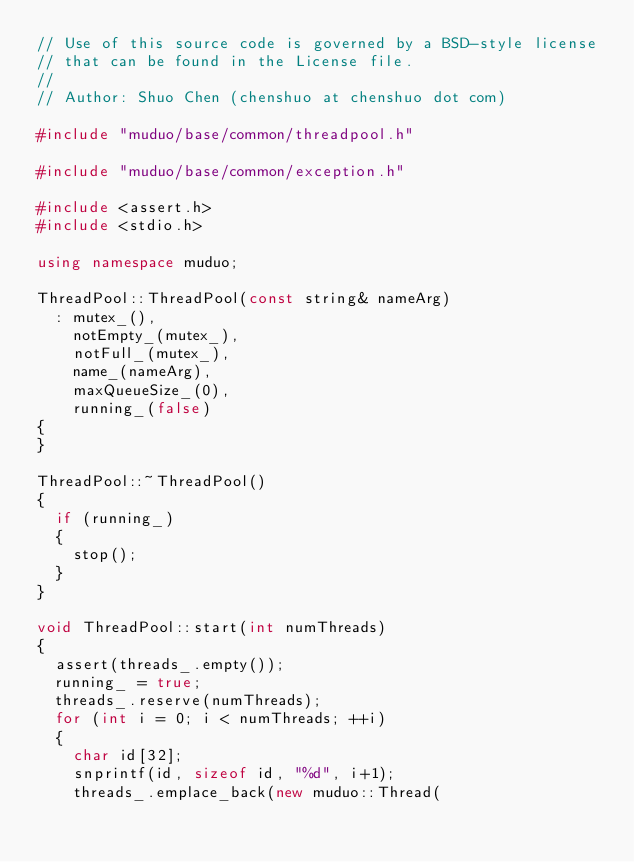Convert code to text. <code><loc_0><loc_0><loc_500><loc_500><_C++_>// Use of this source code is governed by a BSD-style license
// that can be found in the License file.
//
// Author: Shuo Chen (chenshuo at chenshuo dot com)

#include "muduo/base/common/threadpool.h"

#include "muduo/base/common/exception.h"

#include <assert.h>
#include <stdio.h>

using namespace muduo;

ThreadPool::ThreadPool(const string& nameArg)
  : mutex_(),
    notEmpty_(mutex_),
    notFull_(mutex_),
    name_(nameArg),
    maxQueueSize_(0),
    running_(false)
{
}

ThreadPool::~ThreadPool()
{
  if (running_)
  {
    stop();
  }
}

void ThreadPool::start(int numThreads)
{
  assert(threads_.empty());
  running_ = true;
  threads_.reserve(numThreads);
  for (int i = 0; i < numThreads; ++i)
  {
    char id[32];
    snprintf(id, sizeof id, "%d", i+1);
    threads_.emplace_back(new muduo::Thread(</code> 